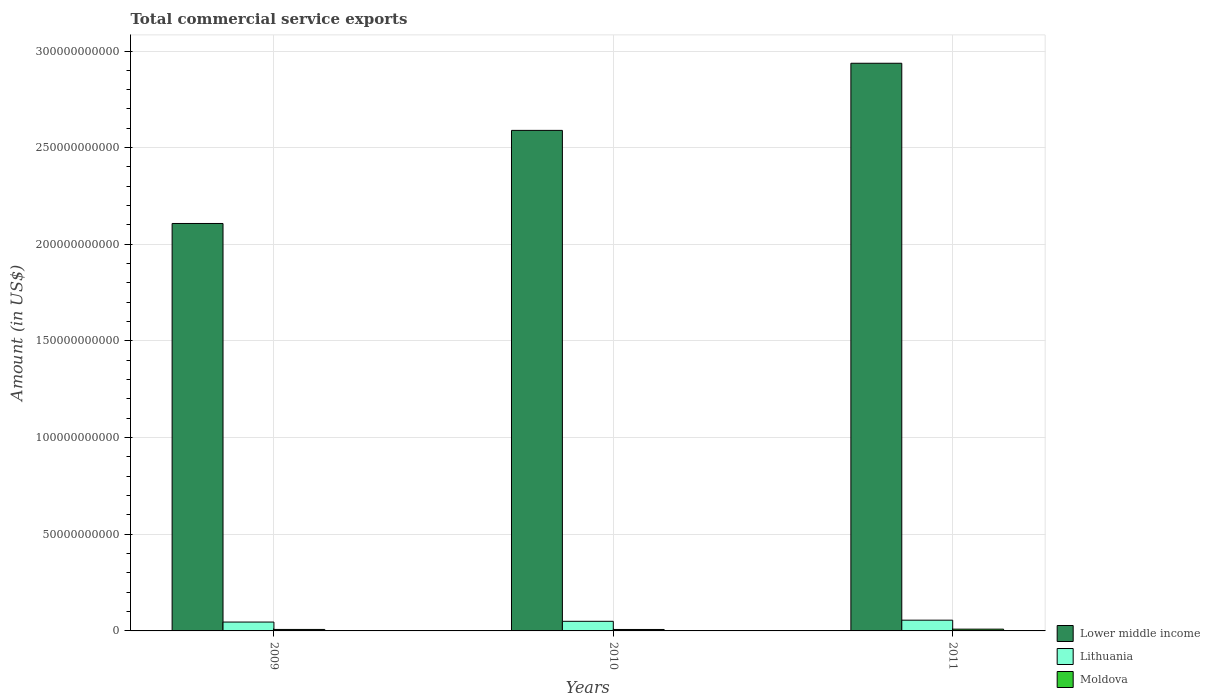How many groups of bars are there?
Keep it short and to the point. 3. How many bars are there on the 3rd tick from the left?
Offer a terse response. 3. What is the label of the 1st group of bars from the left?
Your answer should be compact. 2009. In how many cases, is the number of bars for a given year not equal to the number of legend labels?
Offer a very short reply. 0. What is the total commercial service exports in Lower middle income in 2009?
Your answer should be very brief. 2.11e+11. Across all years, what is the maximum total commercial service exports in Moldova?
Your response must be concise. 9.18e+08. Across all years, what is the minimum total commercial service exports in Moldova?
Your response must be concise. 7.45e+08. In which year was the total commercial service exports in Lower middle income maximum?
Ensure brevity in your answer.  2011. In which year was the total commercial service exports in Moldova minimum?
Your answer should be compact. 2010. What is the total total commercial service exports in Lower middle income in the graph?
Offer a very short reply. 7.63e+11. What is the difference between the total commercial service exports in Lithuania in 2009 and that in 2010?
Make the answer very short. -3.88e+08. What is the difference between the total commercial service exports in Lithuania in 2010 and the total commercial service exports in Lower middle income in 2009?
Provide a short and direct response. -2.06e+11. What is the average total commercial service exports in Lithuania per year?
Your answer should be very brief. 5.04e+09. In the year 2010, what is the difference between the total commercial service exports in Lower middle income and total commercial service exports in Lithuania?
Ensure brevity in your answer.  2.54e+11. In how many years, is the total commercial service exports in Lower middle income greater than 30000000000 US$?
Your answer should be compact. 3. What is the ratio of the total commercial service exports in Lower middle income in 2009 to that in 2010?
Offer a terse response. 0.81. What is the difference between the highest and the second highest total commercial service exports in Moldova?
Provide a succinct answer. 1.54e+08. What is the difference between the highest and the lowest total commercial service exports in Lithuania?
Offer a very short reply. 9.69e+08. In how many years, is the total commercial service exports in Lower middle income greater than the average total commercial service exports in Lower middle income taken over all years?
Your answer should be very brief. 2. What does the 2nd bar from the left in 2010 represents?
Offer a very short reply. Lithuania. What does the 3rd bar from the right in 2010 represents?
Offer a terse response. Lower middle income. Is it the case that in every year, the sum of the total commercial service exports in Lithuania and total commercial service exports in Moldova is greater than the total commercial service exports in Lower middle income?
Keep it short and to the point. No. Are all the bars in the graph horizontal?
Keep it short and to the point. No. How many years are there in the graph?
Offer a terse response. 3. What is the difference between two consecutive major ticks on the Y-axis?
Make the answer very short. 5.00e+1. Does the graph contain any zero values?
Offer a very short reply. No. Does the graph contain grids?
Ensure brevity in your answer.  Yes. Where does the legend appear in the graph?
Give a very brief answer. Bottom right. How are the legend labels stacked?
Give a very brief answer. Vertical. What is the title of the graph?
Your response must be concise. Total commercial service exports. What is the label or title of the X-axis?
Your answer should be compact. Years. What is the Amount (in US$) in Lower middle income in 2009?
Make the answer very short. 2.11e+11. What is the Amount (in US$) of Lithuania in 2009?
Give a very brief answer. 4.59e+09. What is the Amount (in US$) of Moldova in 2009?
Ensure brevity in your answer.  7.64e+08. What is the Amount (in US$) in Lower middle income in 2010?
Your answer should be very brief. 2.59e+11. What is the Amount (in US$) in Lithuania in 2010?
Offer a terse response. 4.97e+09. What is the Amount (in US$) in Moldova in 2010?
Your answer should be compact. 7.45e+08. What is the Amount (in US$) in Lower middle income in 2011?
Offer a terse response. 2.94e+11. What is the Amount (in US$) in Lithuania in 2011?
Offer a very short reply. 5.55e+09. What is the Amount (in US$) in Moldova in 2011?
Offer a very short reply. 9.18e+08. Across all years, what is the maximum Amount (in US$) of Lower middle income?
Provide a short and direct response. 2.94e+11. Across all years, what is the maximum Amount (in US$) in Lithuania?
Keep it short and to the point. 5.55e+09. Across all years, what is the maximum Amount (in US$) in Moldova?
Provide a succinct answer. 9.18e+08. Across all years, what is the minimum Amount (in US$) of Lower middle income?
Ensure brevity in your answer.  2.11e+11. Across all years, what is the minimum Amount (in US$) of Lithuania?
Offer a very short reply. 4.59e+09. Across all years, what is the minimum Amount (in US$) of Moldova?
Your response must be concise. 7.45e+08. What is the total Amount (in US$) in Lower middle income in the graph?
Give a very brief answer. 7.63e+11. What is the total Amount (in US$) in Lithuania in the graph?
Your response must be concise. 1.51e+1. What is the total Amount (in US$) of Moldova in the graph?
Offer a terse response. 2.43e+09. What is the difference between the Amount (in US$) in Lower middle income in 2009 and that in 2010?
Offer a terse response. -4.82e+1. What is the difference between the Amount (in US$) in Lithuania in 2009 and that in 2010?
Offer a very short reply. -3.88e+08. What is the difference between the Amount (in US$) of Moldova in 2009 and that in 2010?
Make the answer very short. 1.86e+07. What is the difference between the Amount (in US$) of Lower middle income in 2009 and that in 2011?
Provide a short and direct response. -8.29e+1. What is the difference between the Amount (in US$) in Lithuania in 2009 and that in 2011?
Make the answer very short. -9.69e+08. What is the difference between the Amount (in US$) of Moldova in 2009 and that in 2011?
Offer a terse response. -1.54e+08. What is the difference between the Amount (in US$) in Lower middle income in 2010 and that in 2011?
Offer a very short reply. -3.47e+1. What is the difference between the Amount (in US$) of Lithuania in 2010 and that in 2011?
Offer a terse response. -5.80e+08. What is the difference between the Amount (in US$) in Moldova in 2010 and that in 2011?
Provide a succinct answer. -1.73e+08. What is the difference between the Amount (in US$) in Lower middle income in 2009 and the Amount (in US$) in Lithuania in 2010?
Your answer should be compact. 2.06e+11. What is the difference between the Amount (in US$) in Lower middle income in 2009 and the Amount (in US$) in Moldova in 2010?
Your answer should be compact. 2.10e+11. What is the difference between the Amount (in US$) of Lithuania in 2009 and the Amount (in US$) of Moldova in 2010?
Offer a very short reply. 3.84e+09. What is the difference between the Amount (in US$) in Lower middle income in 2009 and the Amount (in US$) in Lithuania in 2011?
Your response must be concise. 2.05e+11. What is the difference between the Amount (in US$) in Lower middle income in 2009 and the Amount (in US$) in Moldova in 2011?
Your answer should be compact. 2.10e+11. What is the difference between the Amount (in US$) of Lithuania in 2009 and the Amount (in US$) of Moldova in 2011?
Offer a terse response. 3.67e+09. What is the difference between the Amount (in US$) of Lower middle income in 2010 and the Amount (in US$) of Lithuania in 2011?
Ensure brevity in your answer.  2.53e+11. What is the difference between the Amount (in US$) in Lower middle income in 2010 and the Amount (in US$) in Moldova in 2011?
Make the answer very short. 2.58e+11. What is the difference between the Amount (in US$) in Lithuania in 2010 and the Amount (in US$) in Moldova in 2011?
Offer a very short reply. 4.06e+09. What is the average Amount (in US$) in Lower middle income per year?
Offer a very short reply. 2.54e+11. What is the average Amount (in US$) of Lithuania per year?
Keep it short and to the point. 5.04e+09. What is the average Amount (in US$) in Moldova per year?
Your answer should be compact. 8.09e+08. In the year 2009, what is the difference between the Amount (in US$) in Lower middle income and Amount (in US$) in Lithuania?
Keep it short and to the point. 2.06e+11. In the year 2009, what is the difference between the Amount (in US$) of Lower middle income and Amount (in US$) of Moldova?
Offer a terse response. 2.10e+11. In the year 2009, what is the difference between the Amount (in US$) of Lithuania and Amount (in US$) of Moldova?
Give a very brief answer. 3.82e+09. In the year 2010, what is the difference between the Amount (in US$) in Lower middle income and Amount (in US$) in Lithuania?
Offer a very short reply. 2.54e+11. In the year 2010, what is the difference between the Amount (in US$) in Lower middle income and Amount (in US$) in Moldova?
Keep it short and to the point. 2.58e+11. In the year 2010, what is the difference between the Amount (in US$) of Lithuania and Amount (in US$) of Moldova?
Provide a short and direct response. 4.23e+09. In the year 2011, what is the difference between the Amount (in US$) of Lower middle income and Amount (in US$) of Lithuania?
Ensure brevity in your answer.  2.88e+11. In the year 2011, what is the difference between the Amount (in US$) in Lower middle income and Amount (in US$) in Moldova?
Offer a terse response. 2.93e+11. In the year 2011, what is the difference between the Amount (in US$) of Lithuania and Amount (in US$) of Moldova?
Your answer should be very brief. 4.64e+09. What is the ratio of the Amount (in US$) in Lower middle income in 2009 to that in 2010?
Your response must be concise. 0.81. What is the ratio of the Amount (in US$) of Lithuania in 2009 to that in 2010?
Your response must be concise. 0.92. What is the ratio of the Amount (in US$) of Moldova in 2009 to that in 2010?
Offer a terse response. 1.02. What is the ratio of the Amount (in US$) of Lower middle income in 2009 to that in 2011?
Your answer should be very brief. 0.72. What is the ratio of the Amount (in US$) of Lithuania in 2009 to that in 2011?
Give a very brief answer. 0.83. What is the ratio of the Amount (in US$) in Moldova in 2009 to that in 2011?
Your answer should be very brief. 0.83. What is the ratio of the Amount (in US$) of Lower middle income in 2010 to that in 2011?
Offer a terse response. 0.88. What is the ratio of the Amount (in US$) in Lithuania in 2010 to that in 2011?
Offer a very short reply. 0.9. What is the ratio of the Amount (in US$) in Moldova in 2010 to that in 2011?
Offer a terse response. 0.81. What is the difference between the highest and the second highest Amount (in US$) of Lower middle income?
Offer a terse response. 3.47e+1. What is the difference between the highest and the second highest Amount (in US$) in Lithuania?
Your response must be concise. 5.80e+08. What is the difference between the highest and the second highest Amount (in US$) of Moldova?
Ensure brevity in your answer.  1.54e+08. What is the difference between the highest and the lowest Amount (in US$) of Lower middle income?
Provide a short and direct response. 8.29e+1. What is the difference between the highest and the lowest Amount (in US$) of Lithuania?
Keep it short and to the point. 9.69e+08. What is the difference between the highest and the lowest Amount (in US$) of Moldova?
Give a very brief answer. 1.73e+08. 